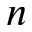<formula> <loc_0><loc_0><loc_500><loc_500>n</formula> 